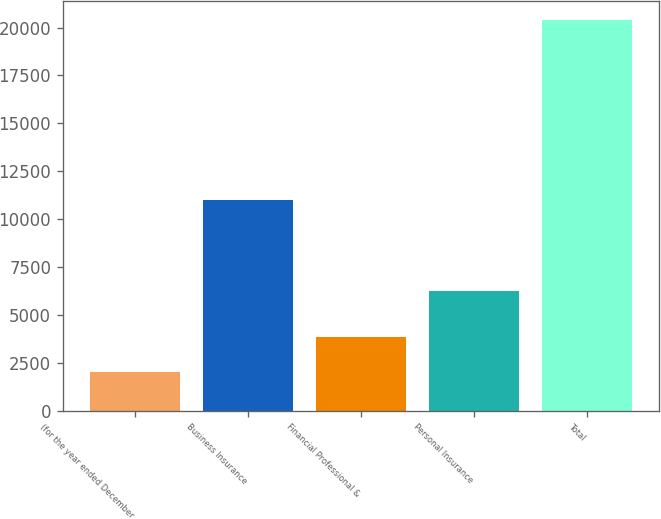<chart> <loc_0><loc_0><loc_500><loc_500><bar_chart><fcel>(for the year ended December<fcel>Business Insurance<fcel>Financial Professional &<fcel>Personal Insurance<fcel>Total<nl><fcel>2005<fcel>10999<fcel>3843.1<fcel>6228<fcel>20386<nl></chart> 